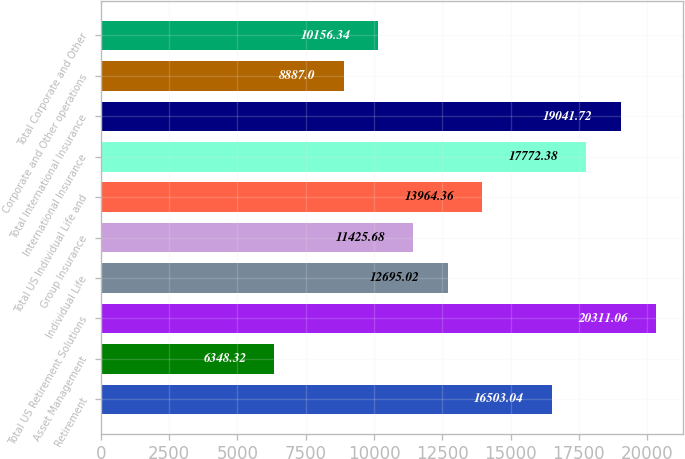Convert chart to OTSL. <chart><loc_0><loc_0><loc_500><loc_500><bar_chart><fcel>Retirement<fcel>Asset Management<fcel>Total US Retirement Solutions<fcel>Individual Life<fcel>Group Insurance<fcel>Total US Individual Life and<fcel>International Insurance<fcel>Total International Insurance<fcel>Corporate and Other operations<fcel>Total Corporate and Other<nl><fcel>16503<fcel>6348.32<fcel>20311.1<fcel>12695<fcel>11425.7<fcel>13964.4<fcel>17772.4<fcel>19041.7<fcel>8887<fcel>10156.3<nl></chart> 